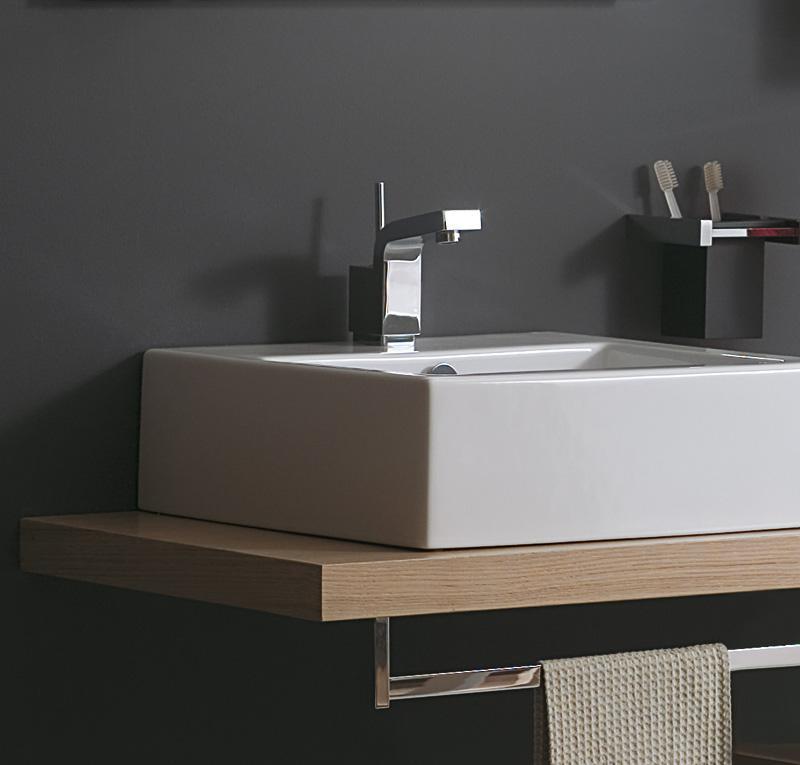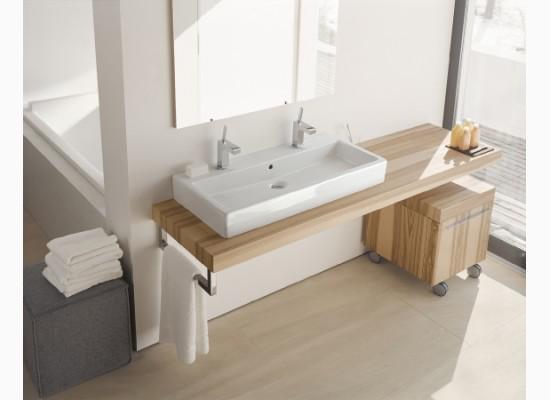The first image is the image on the left, the second image is the image on the right. Considering the images on both sides, is "Both of the basins are rectangular shaped." valid? Answer yes or no. Yes. The first image is the image on the left, the second image is the image on the right. Considering the images on both sides, is "One image shows a square white sink with a single upright chrome faucet fixture on it, atop a brown plank-type counter." valid? Answer yes or no. Yes. 